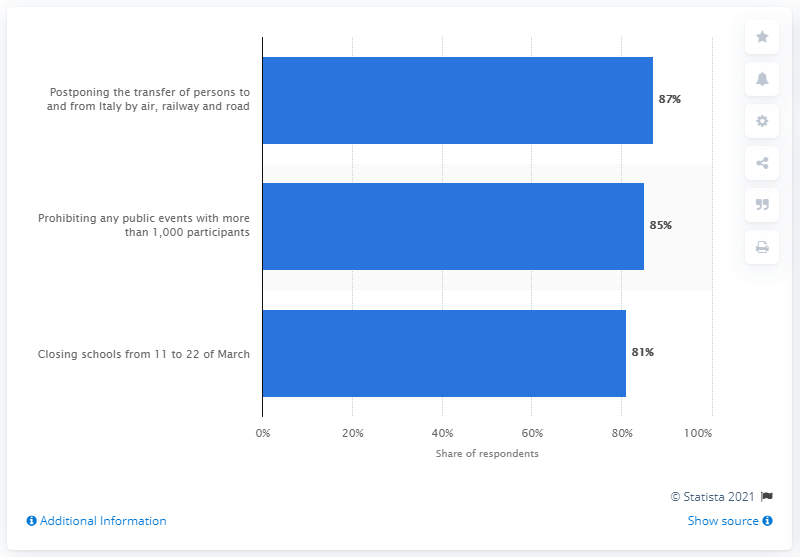Mention a couple of crucial points in this snapshot. A recent survey among Romanians showed that 87% of respondents agreed that the transfer of people to and from Italy should be postponed. 